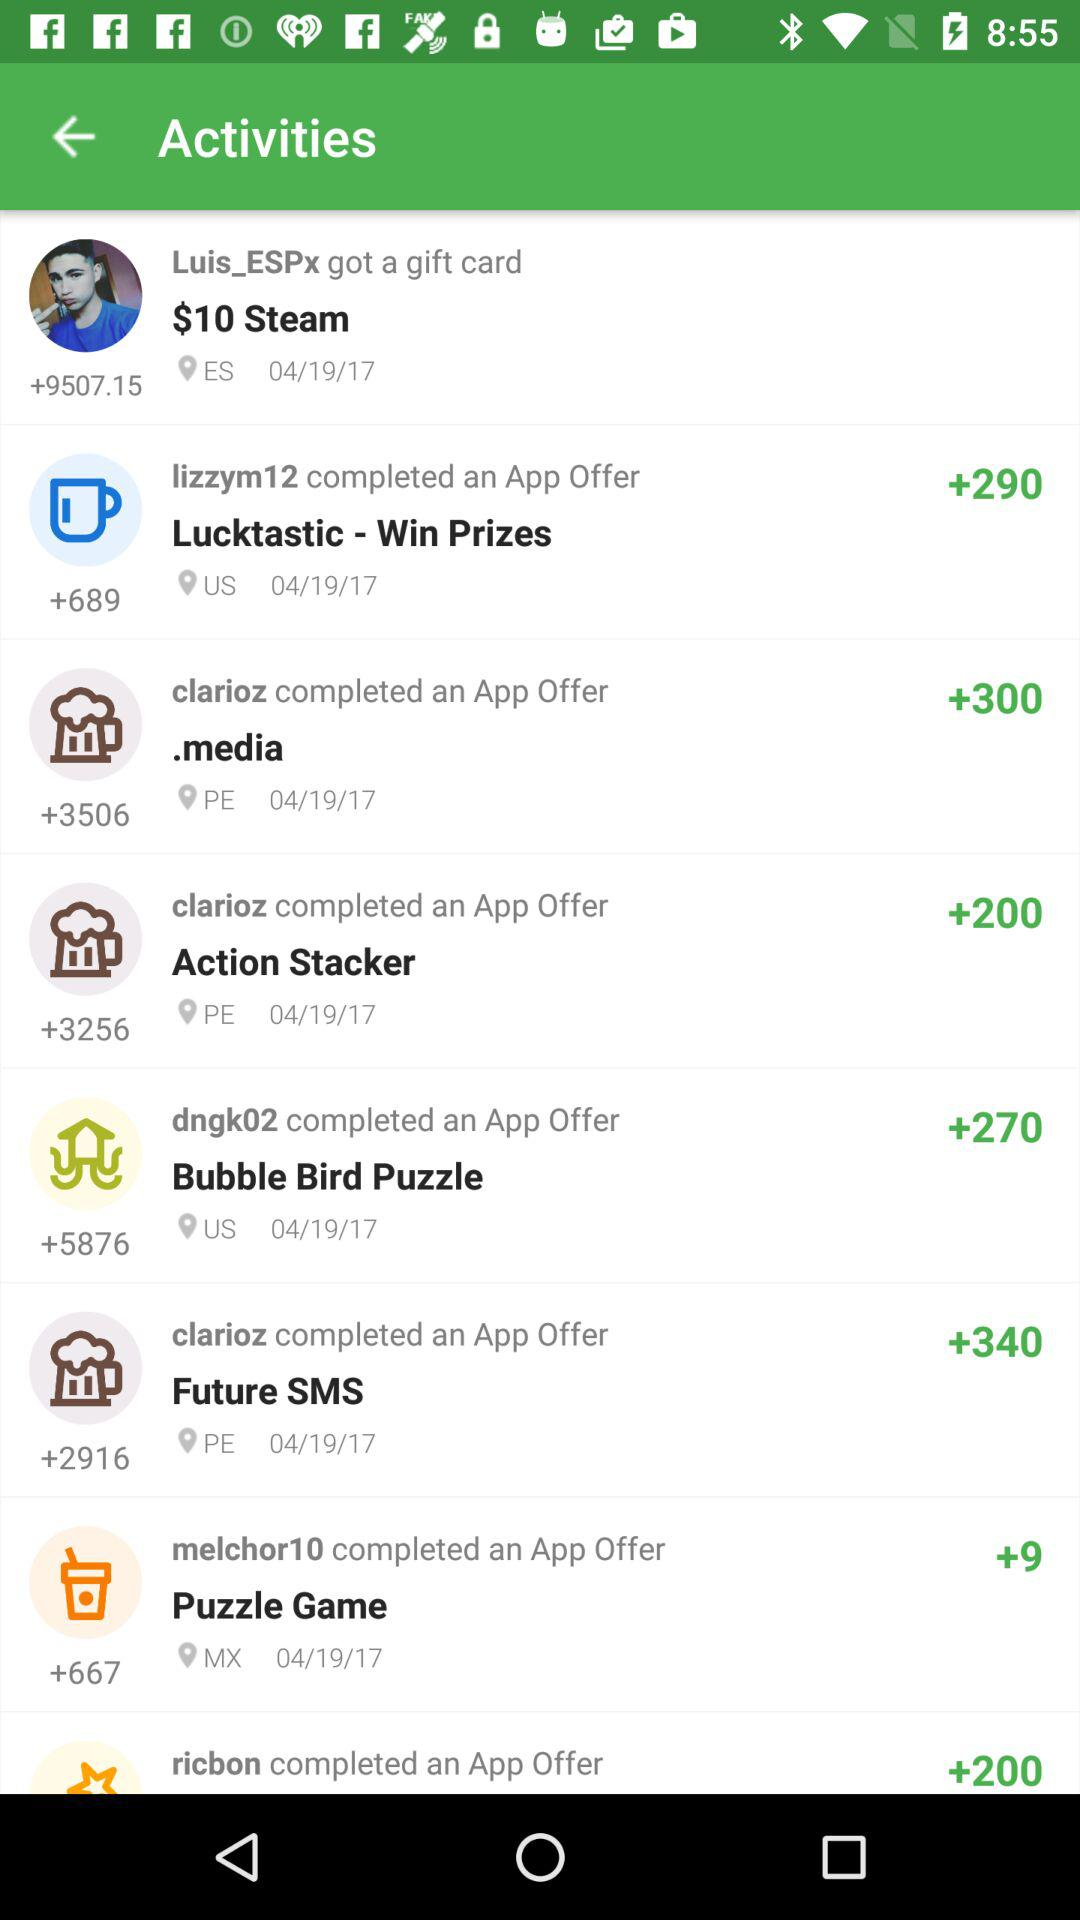Who received a gift card? A gift card was received by "Luis_ESPx". 